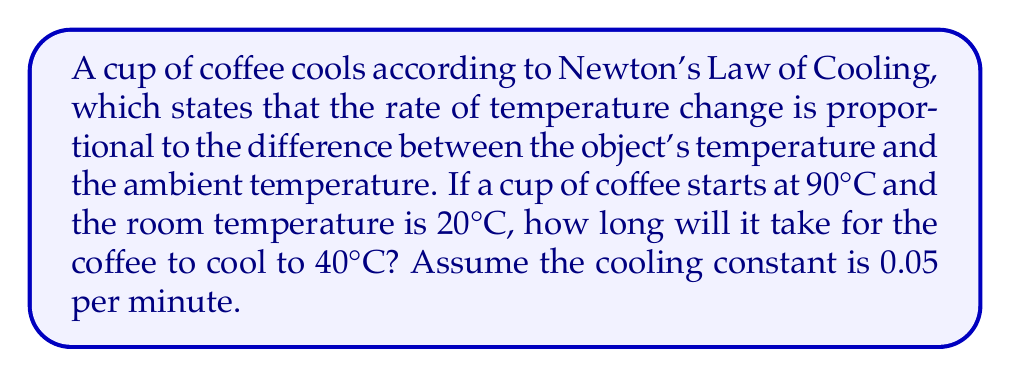Could you help me with this problem? Let's approach this step-by-step:

1) Newton's Law of Cooling is given by the differential equation:

   $$\frac{dT}{dt} = -k(T - T_a)$$

   where $T$ is the temperature of the coffee, $T_a$ is the ambient (room) temperature, $t$ is time, and $k$ is the cooling constant.

2) The solution to this differential equation is:

   $$T(t) = T_a + (T_0 - T_a)e^{-kt}$$

   where $T_0$ is the initial temperature of the coffee.

3) We're given:
   - $T_0 = 90°C$ (initial coffee temperature)
   - $T_a = 20°C$ (room temperature)
   - $k = 0.05$ per minute (cooling constant)
   - We want to find $t$ when $T(t) = 40°C$

4) Let's plug these values into our equation:

   $$40 = 20 + (90 - 20)e^{-0.05t}$$

5) Simplify:

   $$20 = 70e^{-0.05t}$$

6) Divide both sides by 70:

   $$\frac{2}{7} = e^{-0.05t}$$

7) Take the natural log of both sides:

   $$\ln(\frac{2}{7}) = -0.05t$$

8) Solve for $t$:

   $$t = -\frac{\ln(\frac{2}{7})}{0.05} \approx 25.54$$

Therefore, it will take approximately 25.54 minutes for the coffee to cool to 40°C.
Answer: 25.54 minutes 